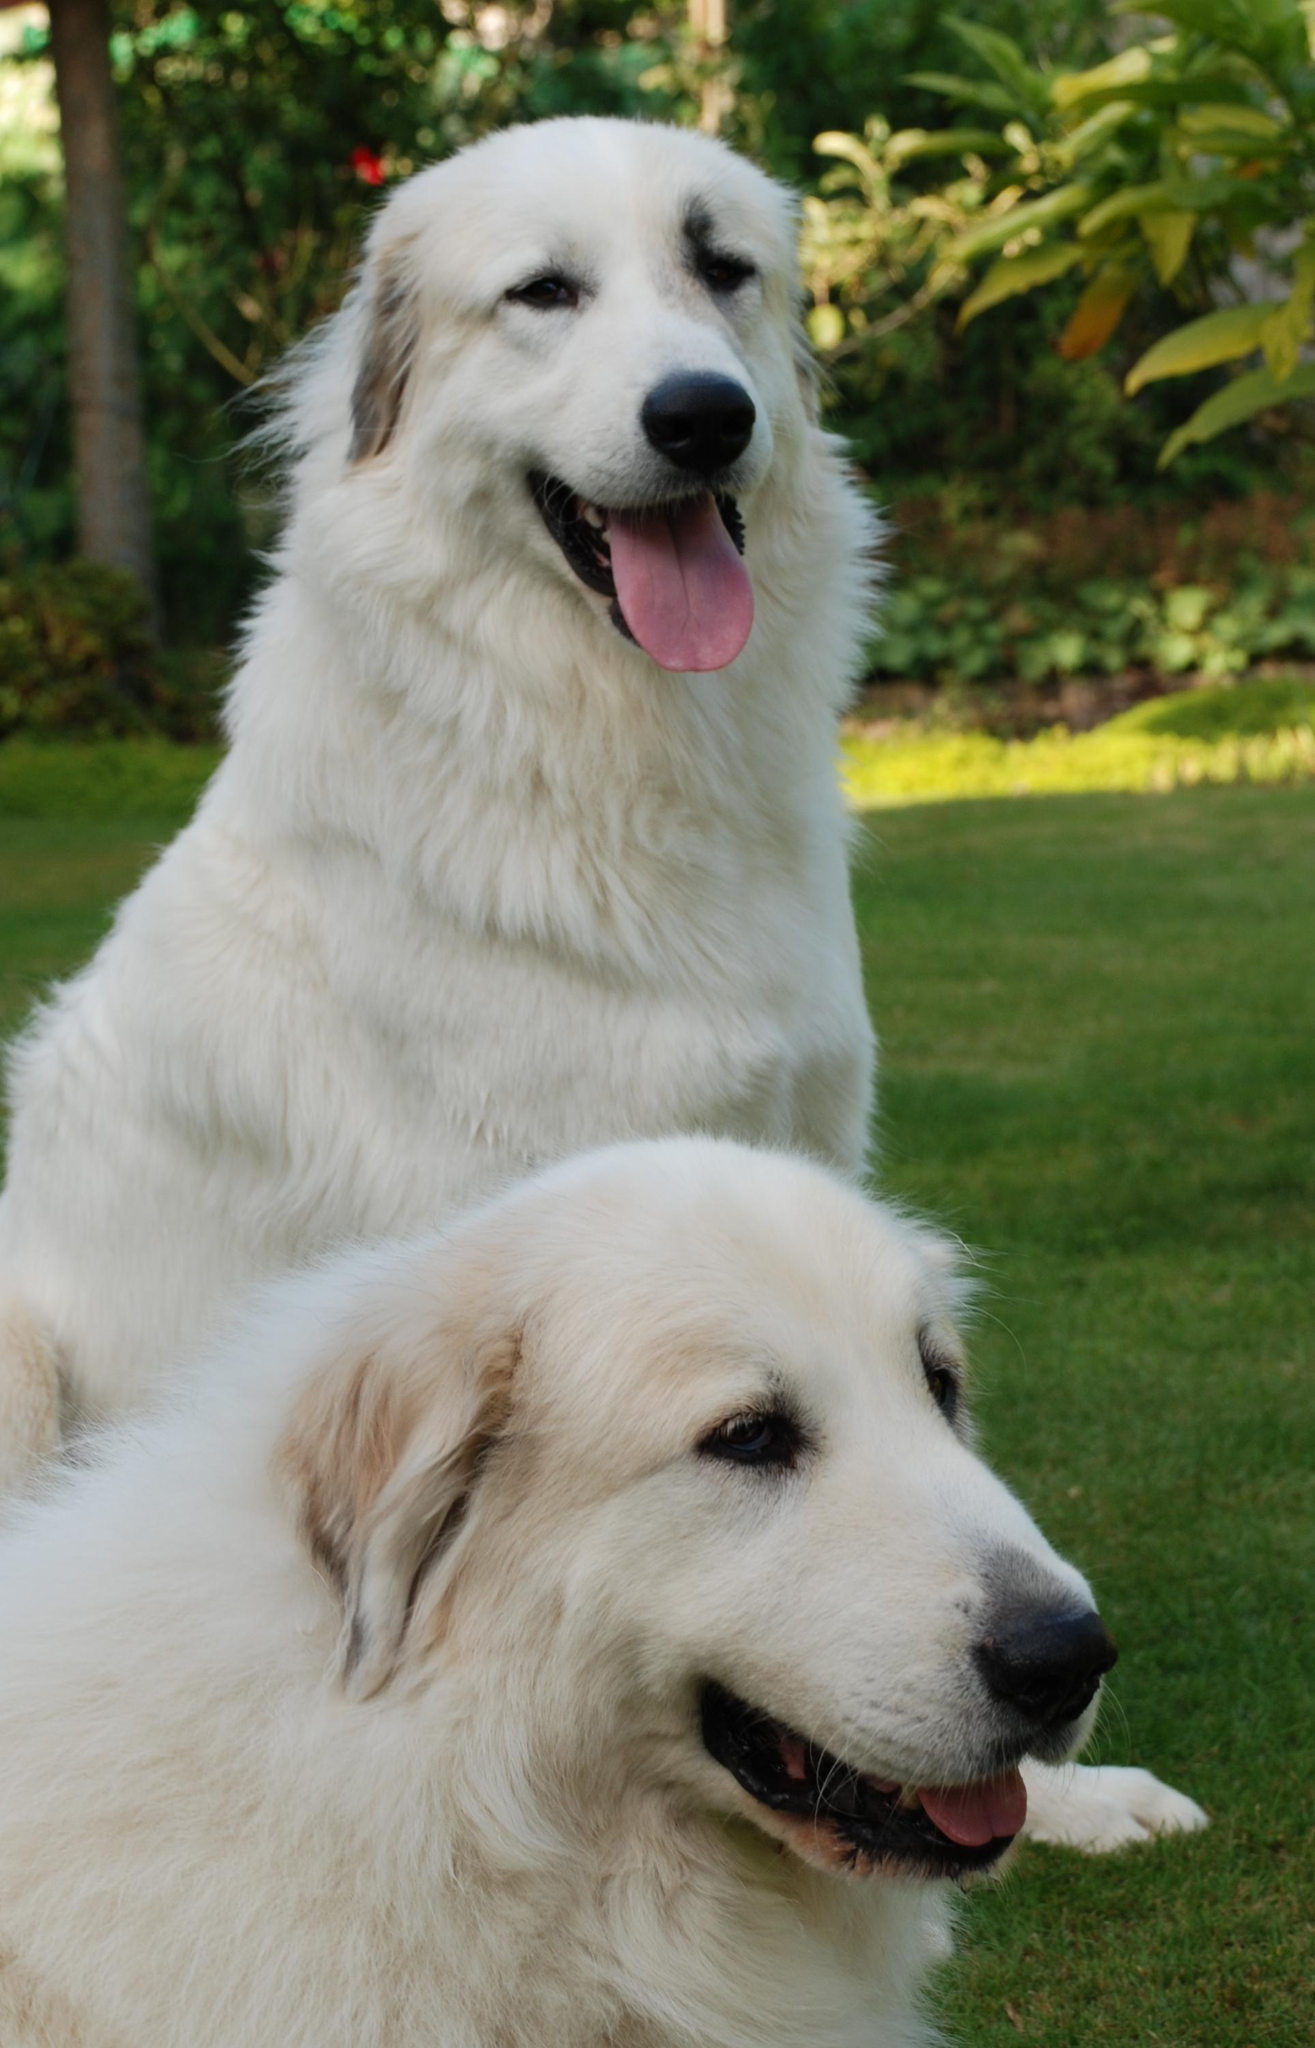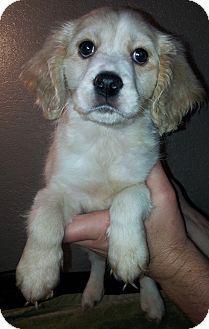The first image is the image on the left, the second image is the image on the right. Examine the images to the left and right. Is the description "At least one image has dogs sitting on grass." accurate? Answer yes or no. Yes. 